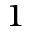<formula> <loc_0><loc_0><loc_500><loc_500>^ { 1 }</formula> 